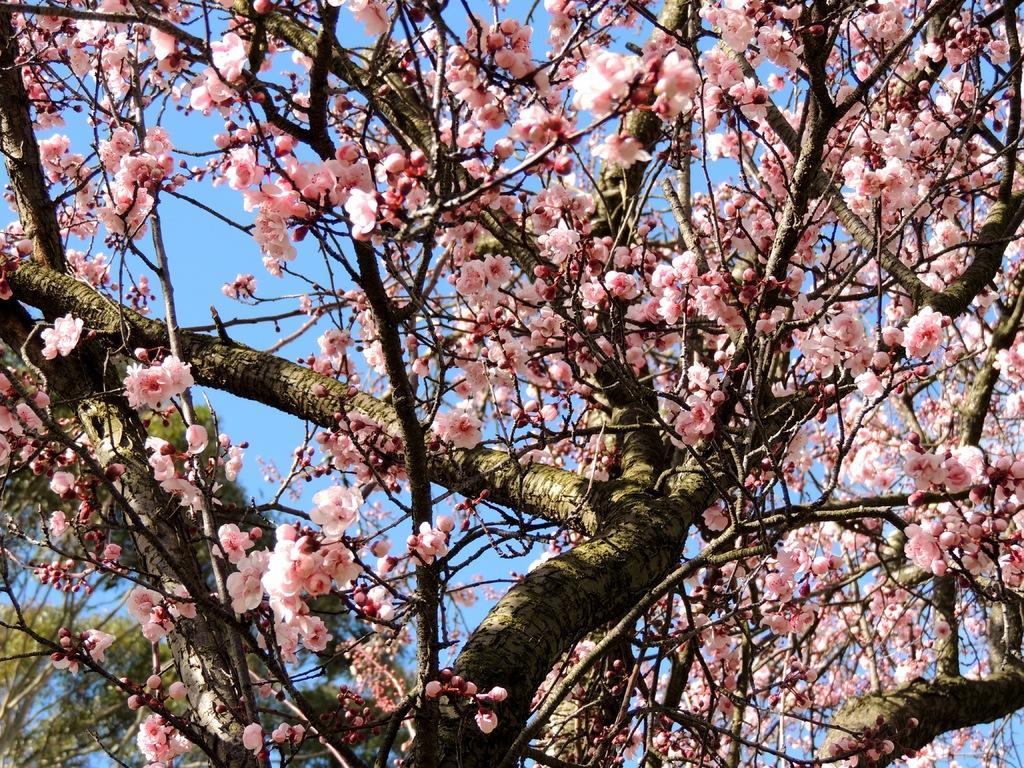In one or two sentences, can you explain what this image depicts? In the image we can see a tree and branches of tree and there are flowers, pale peach in color. Here we can see the blue sky. 